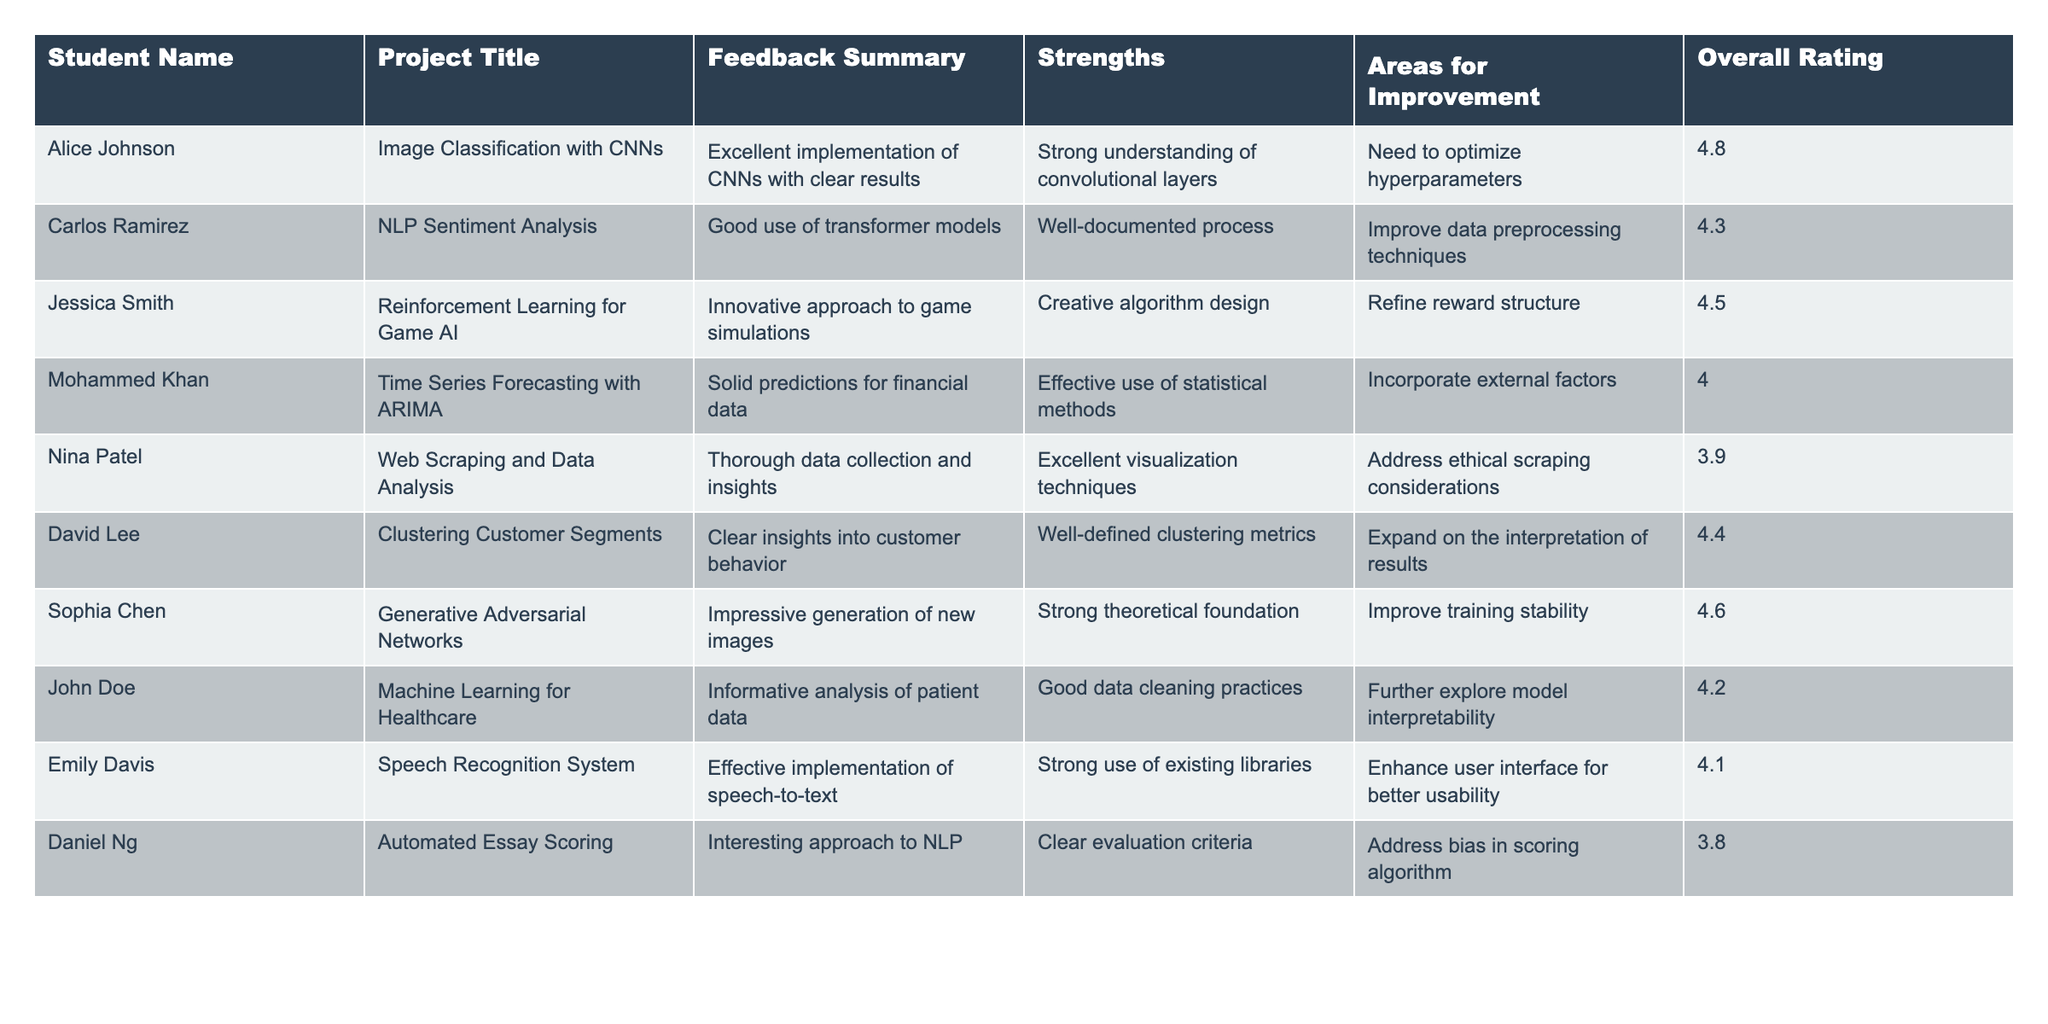What is the overall rating of Alice Johnson's project? The overall rating for Alice Johnson's project, "Image Classification with CNNs," is directly provided in the table. Looking under the "Overall Rating" column, I can see that it is 4.8.
Answer: 4.8 What feedback did Carlos Ramirez receive regarding his data preprocessing techniques? The feedback summary for Carlos Ramirez points out that he needs to improve his data preprocessing techniques. This is mentioned directly under "Areas for Improvement."
Answer: Improve data preprocessing techniques Which project received the lowest overall rating? By comparing the overall ratings for all projects in the table, I can see that Daniel Ng's project, "Automated Essay Scoring," has the lowest rating of 3.8.
Answer: Automated Essay Scoring How many projects received an overall rating above 4.5? I can count the overall ratings in the table that are greater than 4.5. The projects with ratings above 4.5 are Alice Johnson (4.8), Jessica Smith (4.5), Sophia Chen (4.6), and Carlos Ramirez (4.3). That gives us a total of 3 projects.
Answer: 3 Is there any project that focuses on the healthcare domain? The table includes "Machine Learning for Healthcare" by John Doe, which directly relates to the healthcare domain. This is confirmed by reviewing the project titles.
Answer: Yes Which student's project had the strongest theoretical foundation? The feedback for Sophia Chen’s project on Generative Adversarial Networks mentions a "strong theoretical foundation." I find this under the "Strengths" column.
Answer: Sophia Chen What is the average overall rating of all the projects? To calculate the average rating, I sum all the overall ratings and divide by the count of the projects. The overall ratings are 4.8, 4.3, 4.5, 4.0, 3.9, 4.4, 4.6, 4.2, 4.1, and 3.8, which total to 43.6. Dividing by 10 (the number of projects) gives an average rating of 4.36.
Answer: 4.36 Did any students mention the need to address ethical concerns in their projects? Yes, Nina Patel's project, "Web Scraping and Data Analysis," mentions needing to address ethical scraping considerations in the "Areas for Improvement."
Answer: Yes Which student's project focuses on NLP and what was the feedback given? Carlos Ramirez's project focuses on NLP with sentiment analysis. The feedback provided states that it had a good use of transformer models, with well-documented processes.
Answer: Carlos Ramirez, Good use of transformer models How many strengths did Daniel Ng's project have mentioned? While reviewing Daniel Ng’s project in the "Strengths" column, I see only one noted strength, which is "Interesting approach to NLP." Therefore, the count of strengths mentioned is one.
Answer: 1 